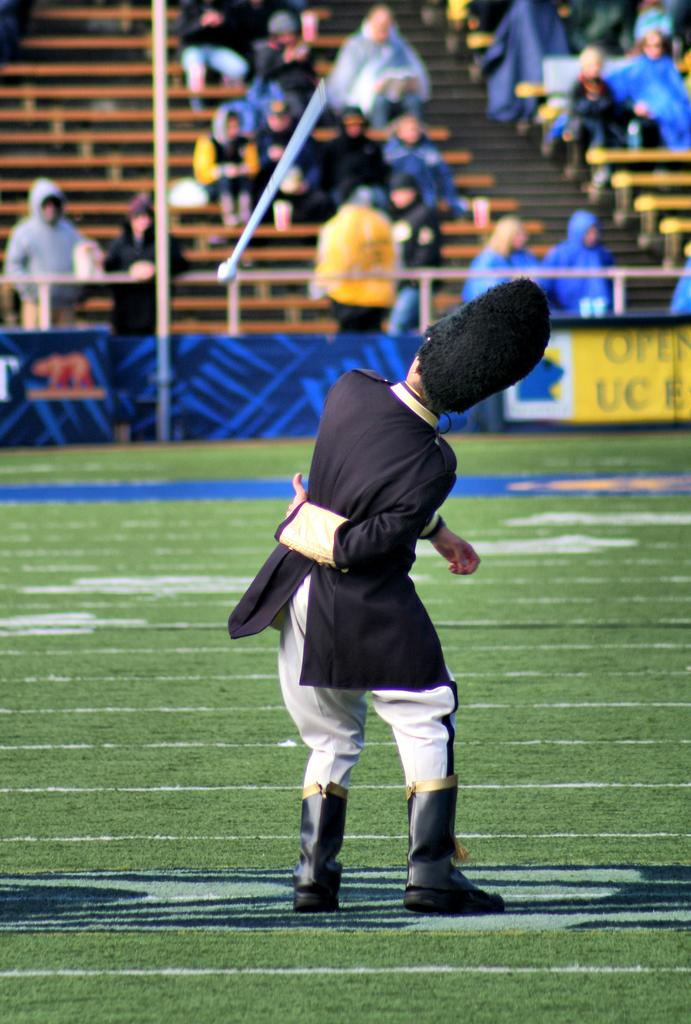What type of structure is visible in the image? There is a stadium in the image. What can be found on the ground inside the stadium? There is grass in the stadium. Are there any people present in the image? Yes, there are people in the stadium. What else can be seen in the stadium besides the grass and people? Banners and poles are present in the stadium. What are some people doing in the stadium? Some people are sitting on benches in the stadium. Can you describe the hair of the laborer working at the seashore in the image? There is no laborer working at the seashore in the image, nor is there any hair to describe. 